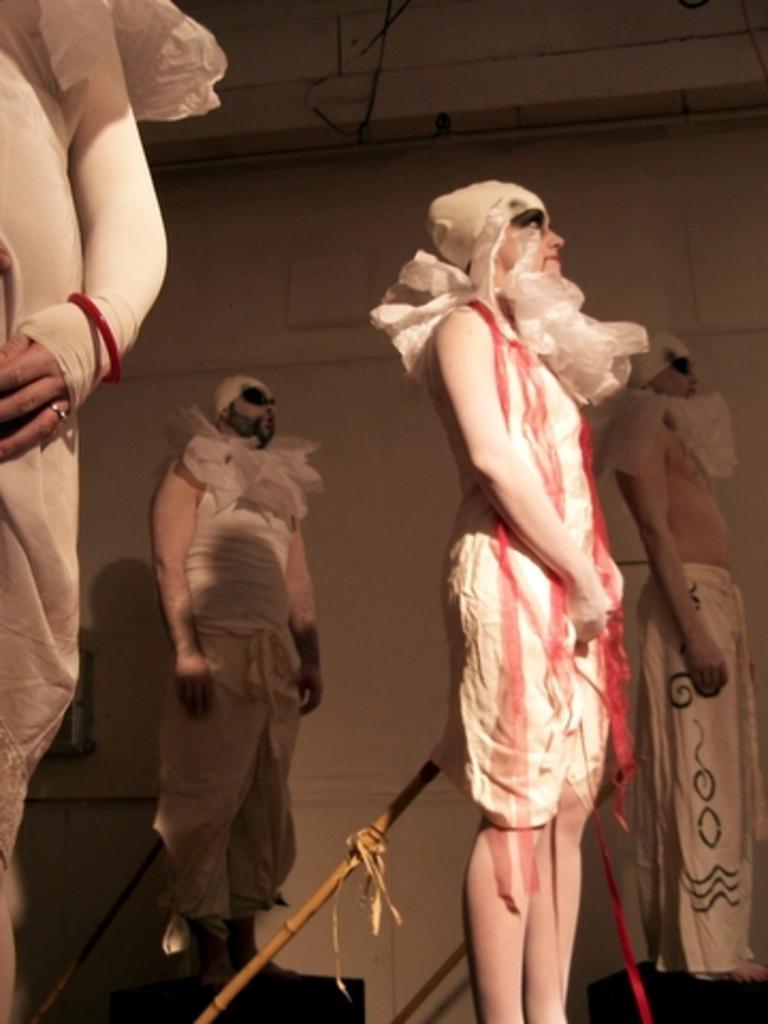Please provide a concise description of this image. In this image, I can see four persons standing with fancy dresses and there are wooden sticks. In the background there is a wall. 